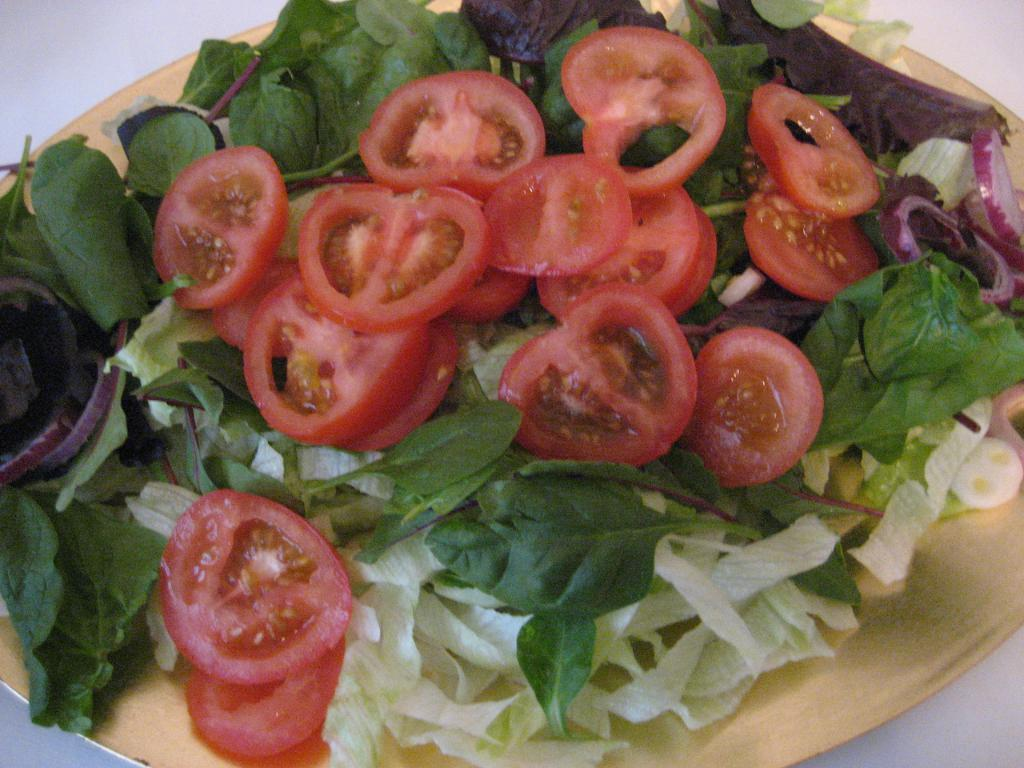What type of vegetables can be seen in the image? There are chopped tomatoes, chopped onions, and leafy vegetables in the image. Can you describe the state of the vegetables in the image? The vegetables are chopped in the image. What type of fear can be seen in the image? There is no fear present in the image; it features chopped vegetables. Are there any sisters depicted in the image? There are no people, let alone sisters, present in the image. 